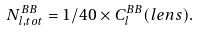Convert formula to latex. <formula><loc_0><loc_0><loc_500><loc_500>N _ { l , t o t } ^ { B B } = 1 / 4 0 \times C _ { l } ^ { B B } ( l e n s ) .</formula> 